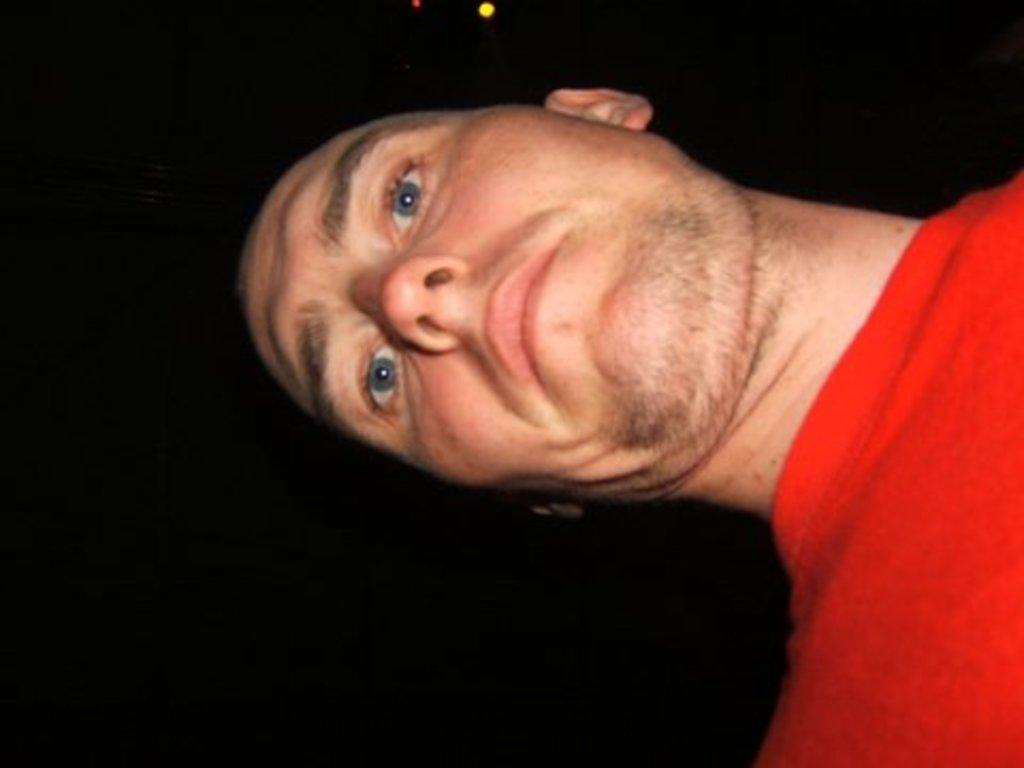What is the main subject of the image? There is a person in the image. What is the person wearing in the image? The person is wearing a red t-shirt. What color is the background of the image? The background of the image is black. What type of flag is being waved by the person in the image? There is no flag present in the image, and the person is not waving anything. 